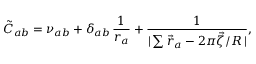<formula> <loc_0><loc_0><loc_500><loc_500>\tilde { C } _ { a b } = \nu _ { a b } + \delta _ { a b } \, \frac { 1 } { r _ { a } } + \frac { 1 } { | \sum \vec { r } _ { a } - 2 \pi \vec { \zeta } / R \, | } ,</formula> 